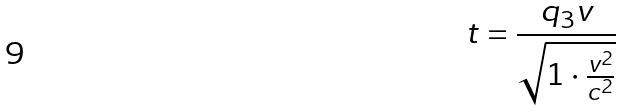Convert formula to latex. <formula><loc_0><loc_0><loc_500><loc_500>t = \frac { q _ { 3 } v } { \sqrt { 1 \cdot \frac { v ^ { 2 } } { c ^ { 2 } } } }</formula> 